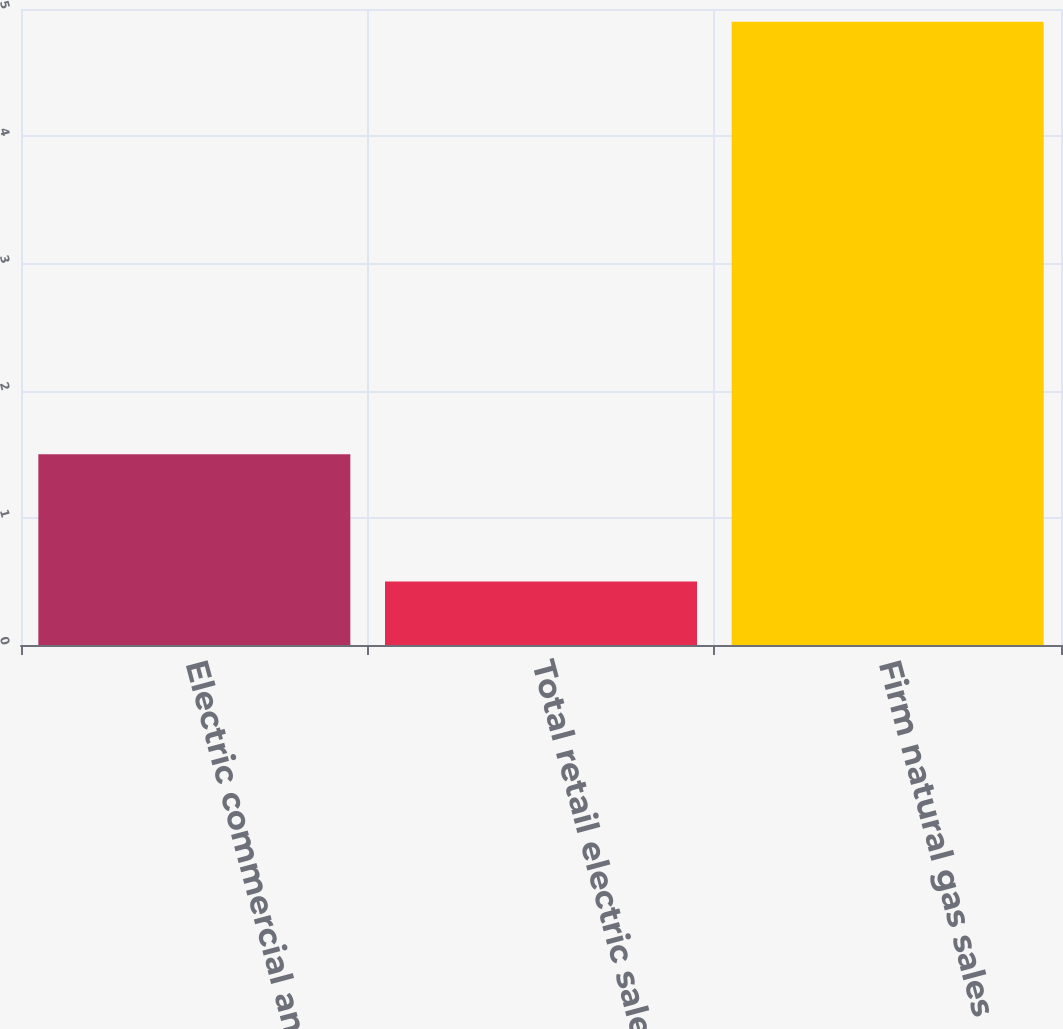<chart> <loc_0><loc_0><loc_500><loc_500><bar_chart><fcel>Electric commercial and<fcel>Total retail electric sales<fcel>Firm natural gas sales<nl><fcel>1.5<fcel>0.5<fcel>4.9<nl></chart> 